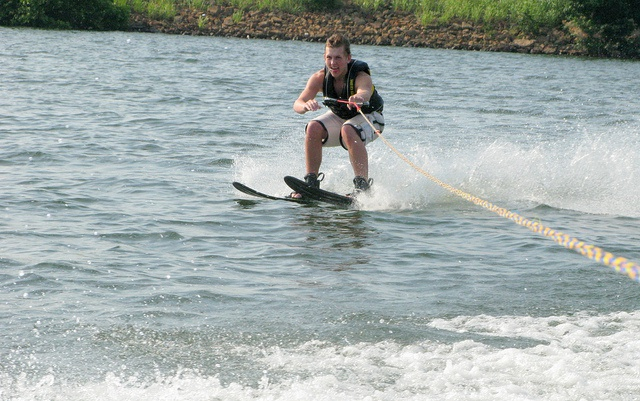Describe the objects in this image and their specific colors. I can see people in black, gray, darkgray, and lightgray tones and skis in black, gray, lightgray, and darkgray tones in this image. 